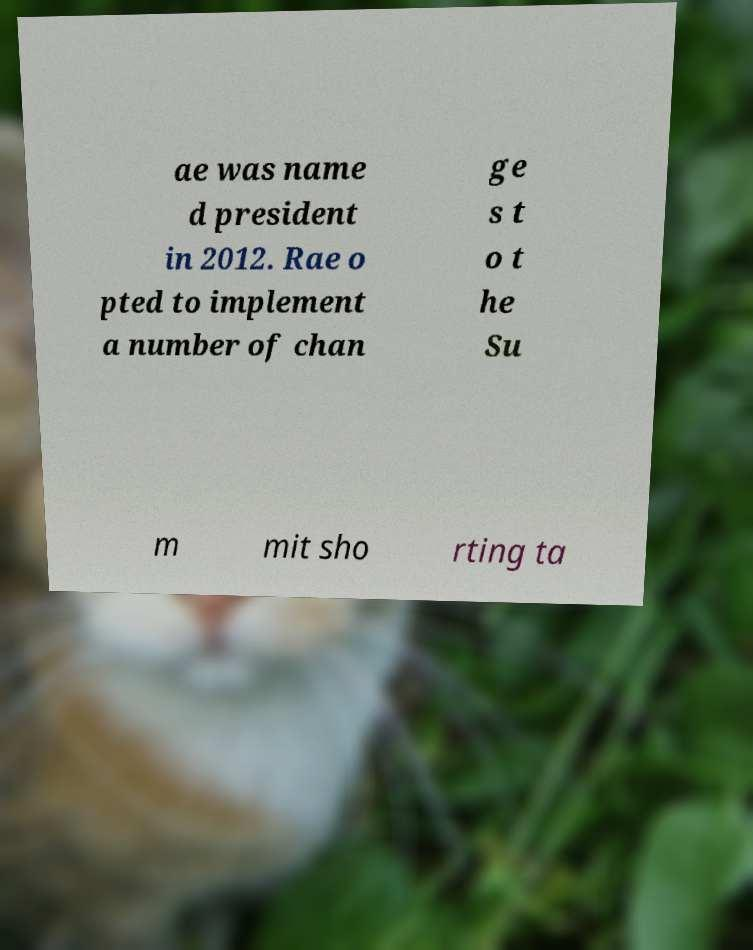There's text embedded in this image that I need extracted. Can you transcribe it verbatim? ae was name d president in 2012. Rae o pted to implement a number of chan ge s t o t he Su m mit sho rting ta 